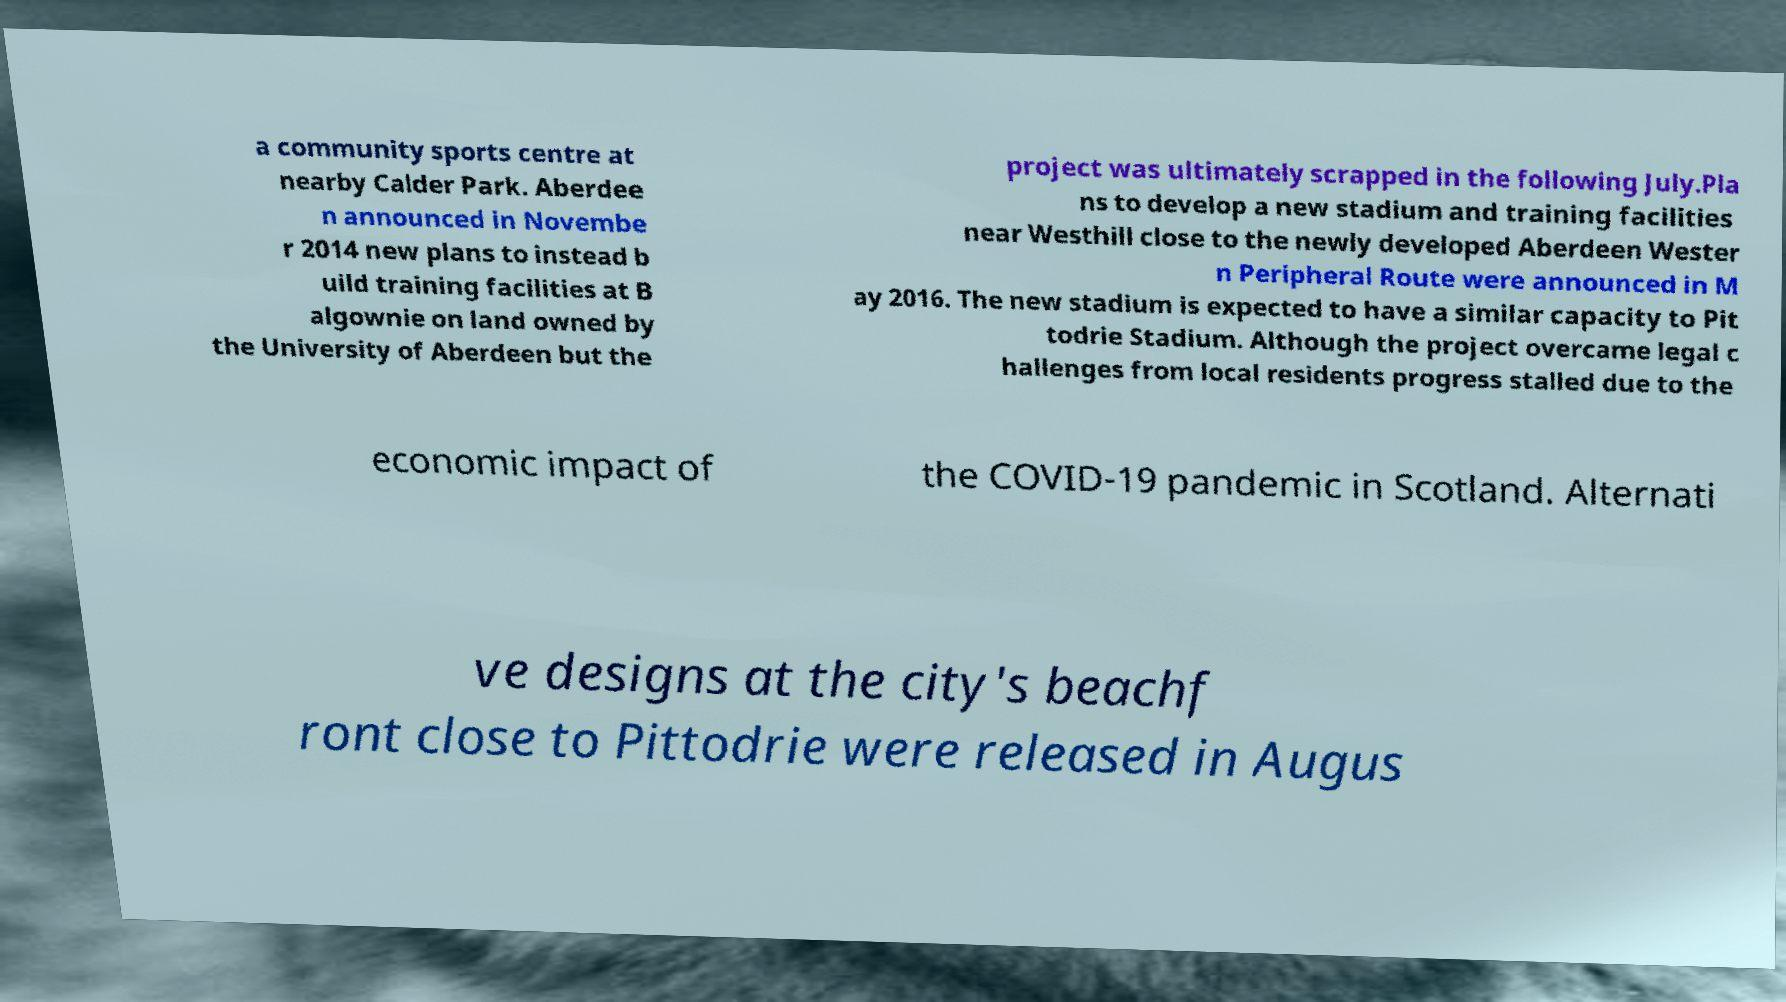Can you accurately transcribe the text from the provided image for me? a community sports centre at nearby Calder Park. Aberdee n announced in Novembe r 2014 new plans to instead b uild training facilities at B algownie on land owned by the University of Aberdeen but the project was ultimately scrapped in the following July.Pla ns to develop a new stadium and training facilities near Westhill close to the newly developed Aberdeen Wester n Peripheral Route were announced in M ay 2016. The new stadium is expected to have a similar capacity to Pit todrie Stadium. Although the project overcame legal c hallenges from local residents progress stalled due to the economic impact of the COVID-19 pandemic in Scotland. Alternati ve designs at the city's beachf ront close to Pittodrie were released in Augus 